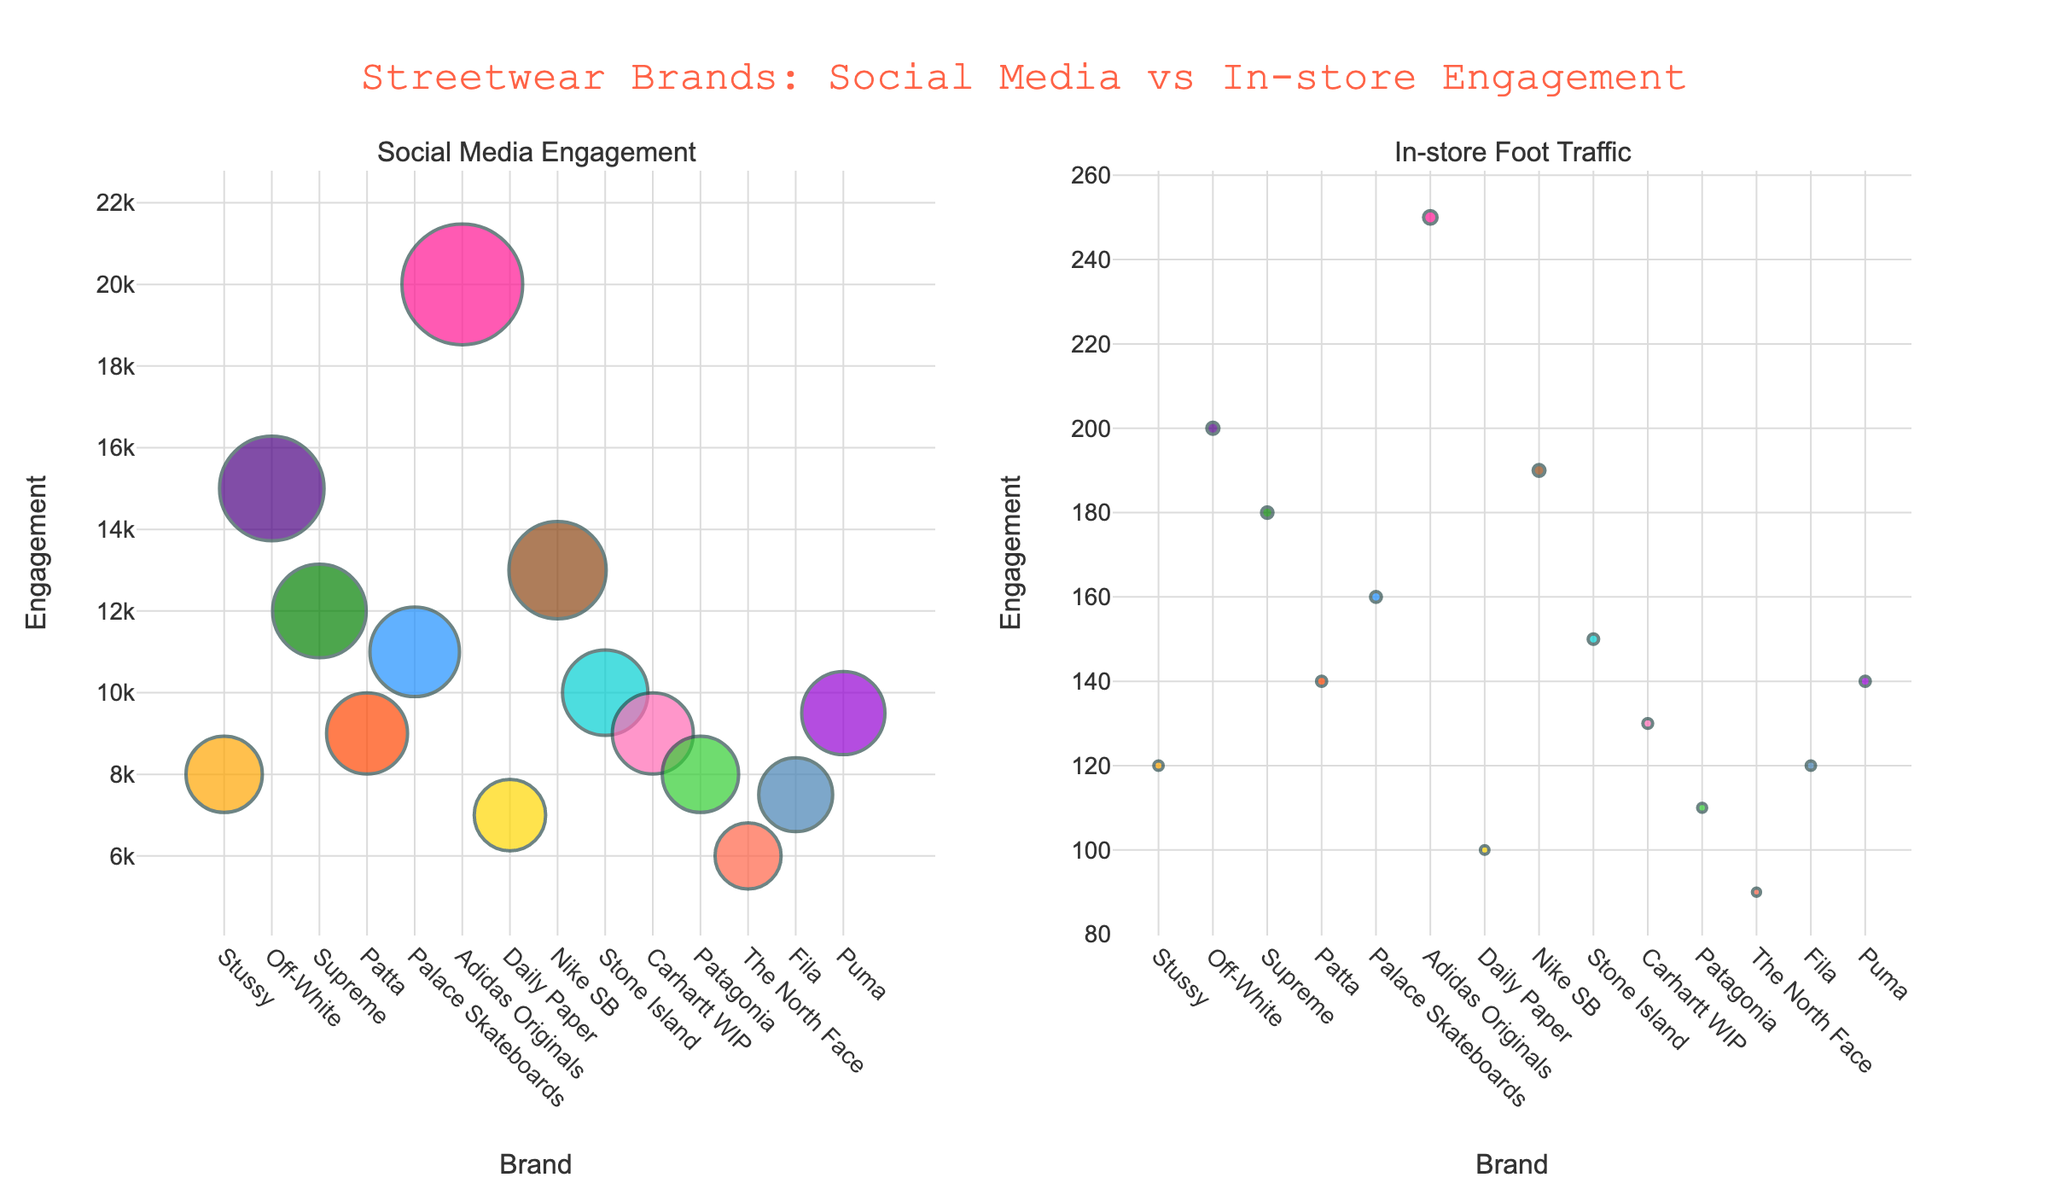What is the title of the figure? The title is usually located at the top of the figure. Here, it reads "Streetwear Brands: Social Media vs In-store Engagement".
Answer: "Streetwear Brands: Social Media vs In-store Engagement" Which city is associated with Off-White? By hovering over the Off-White marker on either subplot, the text shows "City: London".
Answer: London How many brands are plotted in each subplot? Each marker represents a brand and the x-axis lists the brands. Counting them reveals there are 14 brands.
Answer: 14 Which brand has the highest in-store foot traffic? Looking at the "In-store Foot Traffic" subplot, the highest point on the y-axis corresponds to Adidas Originals.
Answer: Adidas Originals How does the social media engagement for Stone Island compare to Puma? In the "Social Media Engagement" subplot, Stone Island has 10,000 while Puma has 9,500, so Stone Island has higher engagement.
Answer: Stone Island What is the sum of social media engagement for all brands located in Amsterdam? Adding the engagement values for Amsterdam brands: Stussy (8000) + Patta (9000) + Daily Paper (7000) = 24,000.
Answer: 24,000 Which brand has the smallest marker size in the "In-store Foot Traffic" subplot? The smallest marker at a quick glance seems to represent The North Face, which has the lowest foot traffic of 90.
Answer: The North Face Is there a city represented more than once in the figure? If so, which one is it? Checking the hover text across the subplots, "Amsterdam" appears multiple times for Stussy, Patta, and Daily Paper.
Answer: Amsterdam What pattern can you observe between high social media engagement and in-store foot traffic? Higher social media engagement generally correlates with higher in-store foot traffic, as seen in Adidas Originals and Off-White.
Answer: Positive correlation 